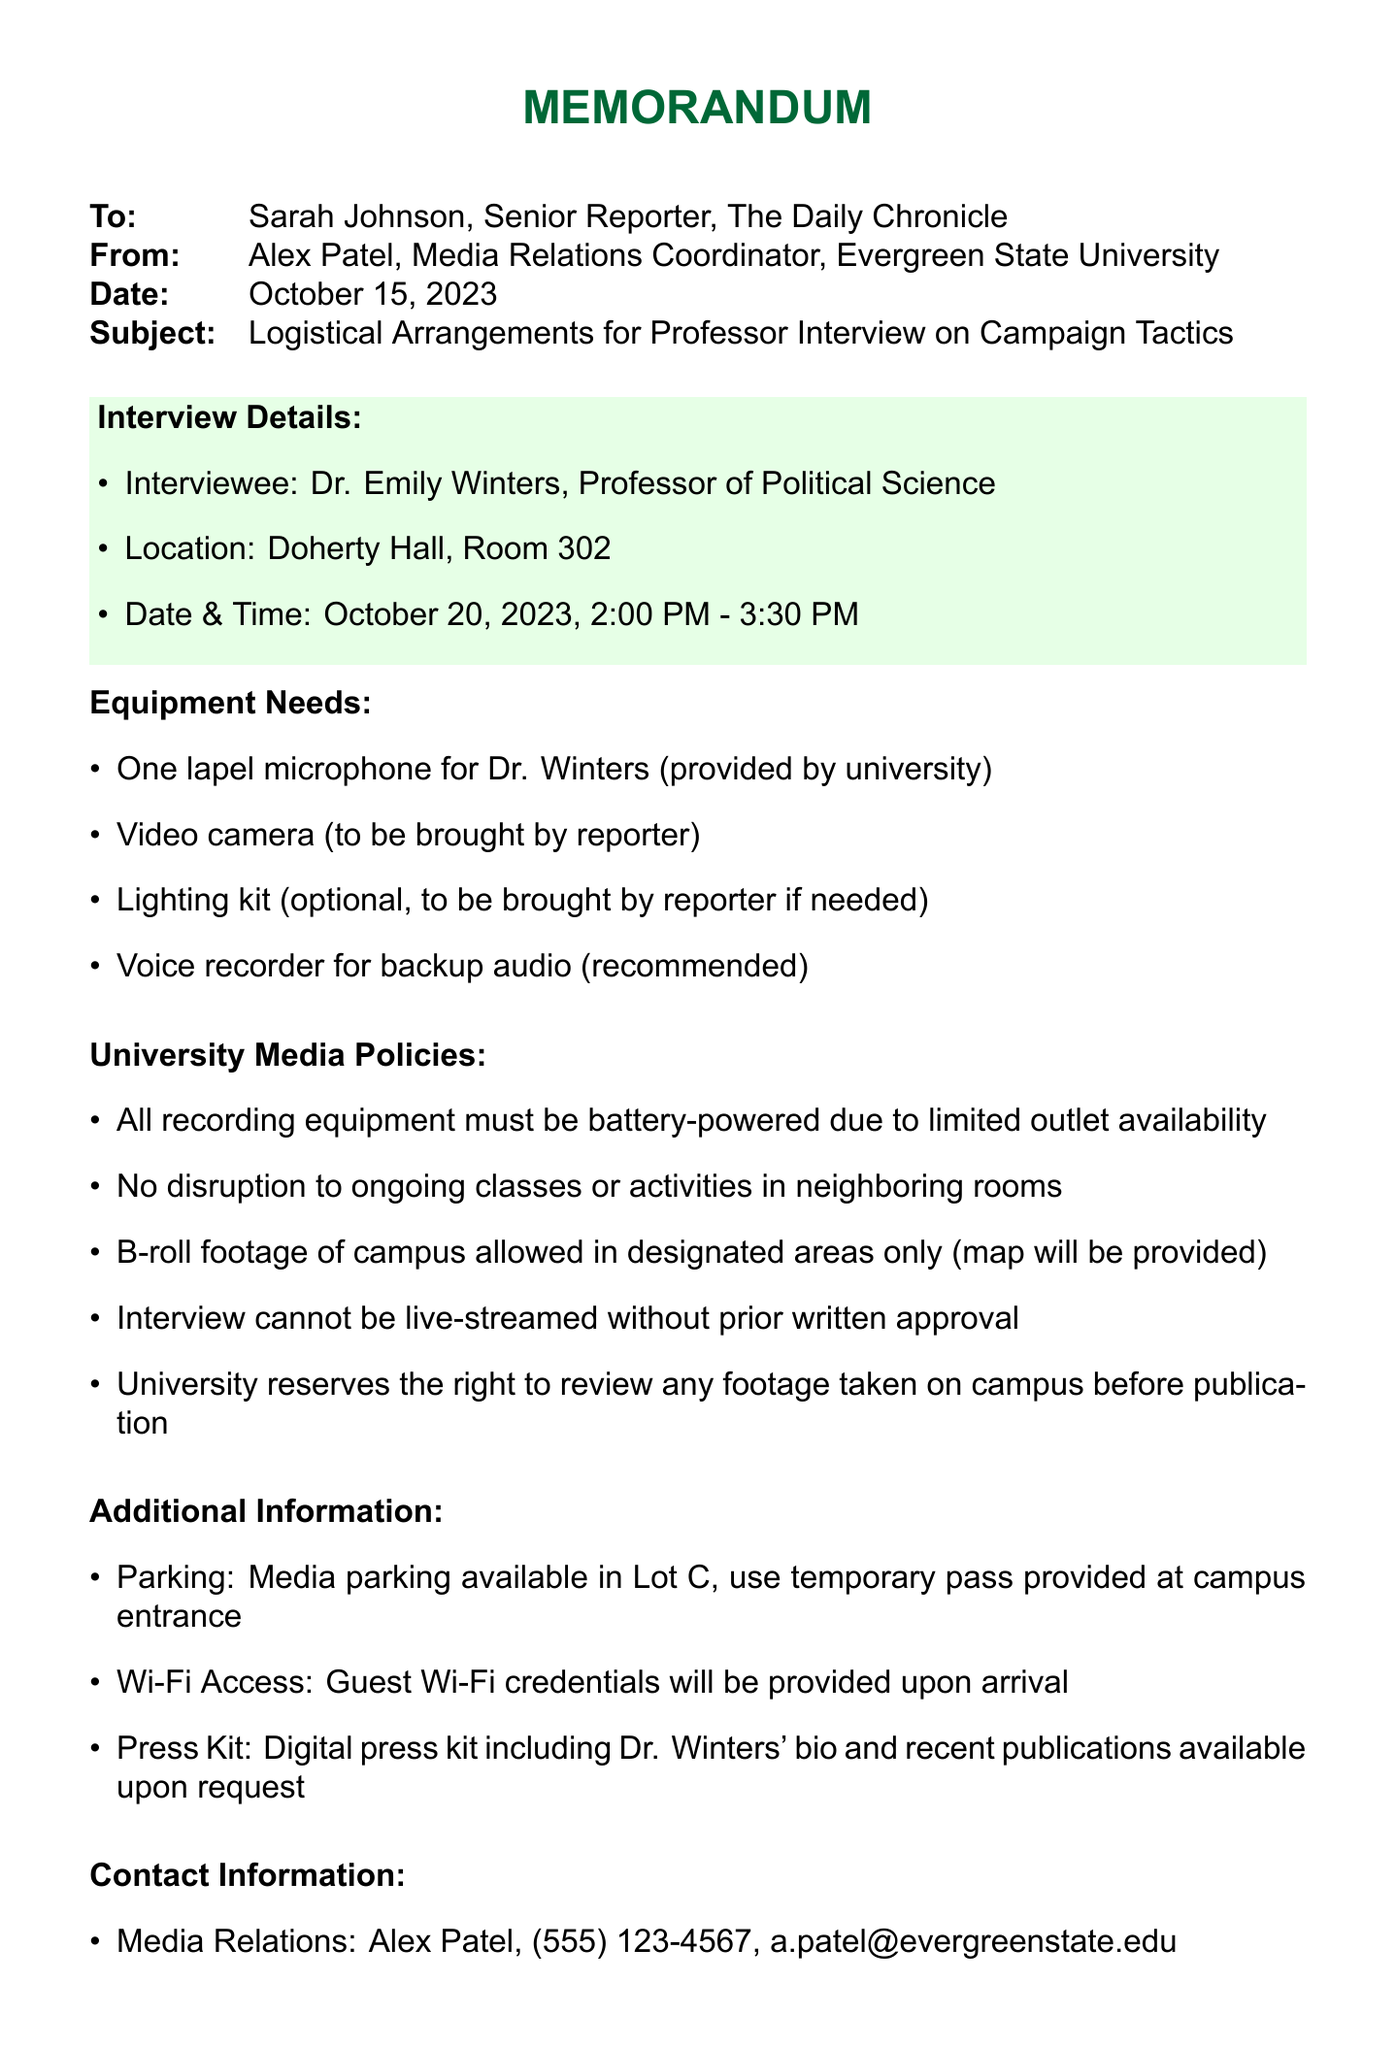What is the name of the interviewee? The interviewee is specified in the document as Dr. Emily Winters, Professor of Political Science.
Answer: Dr. Emily Winters When is the interview scheduled? The date and time for the interview are clearly mentioned as October 20, 2023, from 2:00 PM to 3:30 PM.
Answer: October 20, 2023, 2:00 PM - 3:30 PM What equipment is provided by the university? The memo lists equipment needs and specifies that one lapel microphone for Dr. Winters will be provided by the university.
Answer: One lapel microphone What special consideration has Dr. Winters requested? The document states a specific request from Dr. Winters regarding the exclusion of questions about ongoing legal cases related to campaign finance.
Answer: No questions about ongoing legal cases Where will the interview take place? The location for the interview is detailed as Doherty Hall, Room 302.
Answer: Doherty Hall, Room 302 What is the policy for recording equipment? One of the university media policies states that all recording equipment must be battery-powered due to limited outlet availability.
Answer: Battery-powered What is included in the digital press kit? The memo indicates that the digital press kit includes Dr. Winters' bio and recent publications.
Answer: Dr. Winters' bio and recent publications What is the contact number for media relations? The contact information in the document provides Alex Patel's phone number for media relations coordination.
Answer: (555) 123-4567 